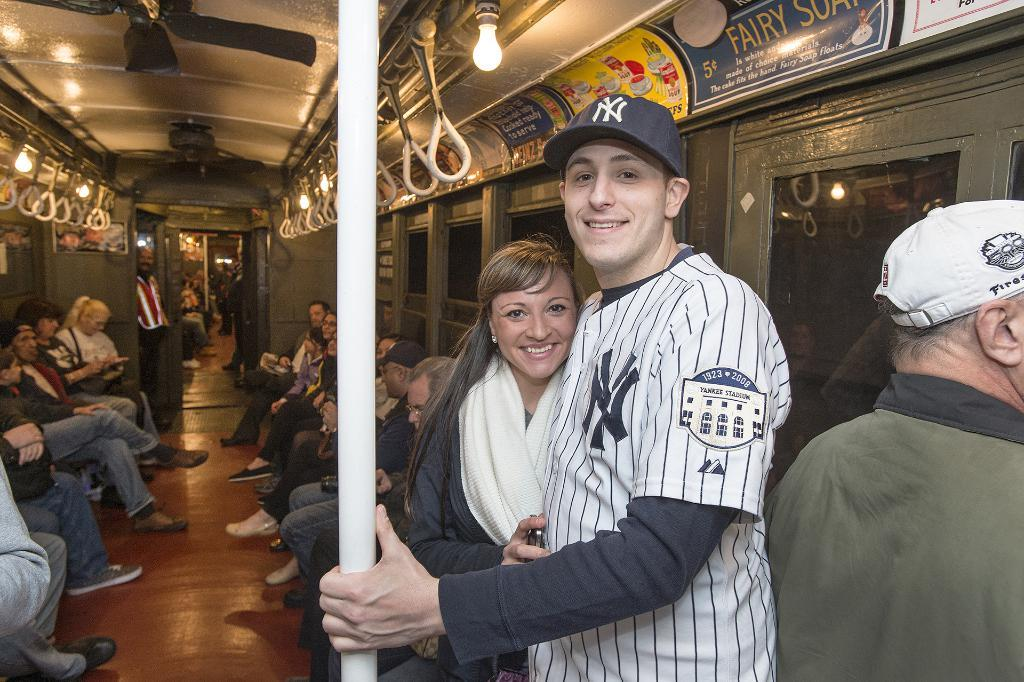<image>
Create a compact narrative representing the image presented. a NY logo that is on a baseball jersey 